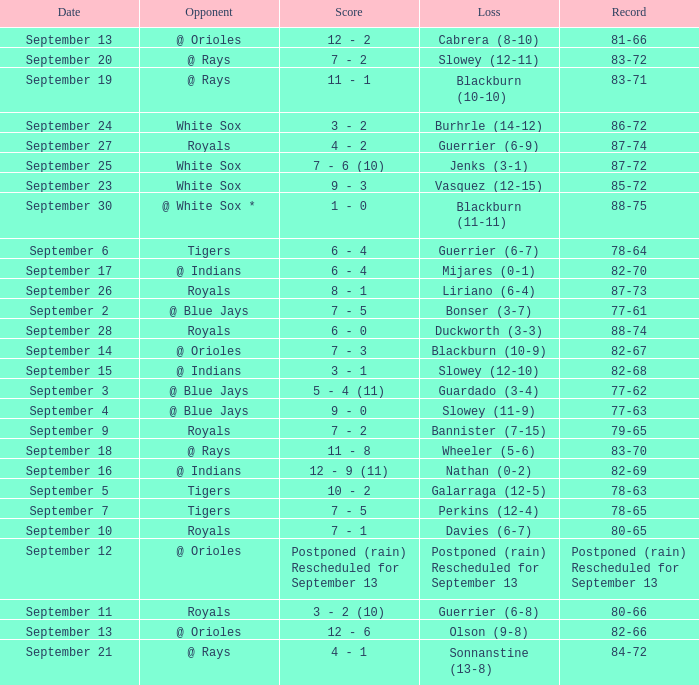What date has the record of 77-62? September 3. 